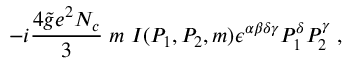Convert formula to latex. <formula><loc_0><loc_0><loc_500><loc_500>- i \frac { 4 \widetilde { g } e ^ { 2 } N _ { c } } { 3 } \, m \, I ( P _ { 1 } , P _ { 2 } , m ) \epsilon ^ { \alpha \beta \delta \gamma } P _ { 1 } ^ { \delta } P _ { 2 } ^ { \gamma } \, ,</formula> 